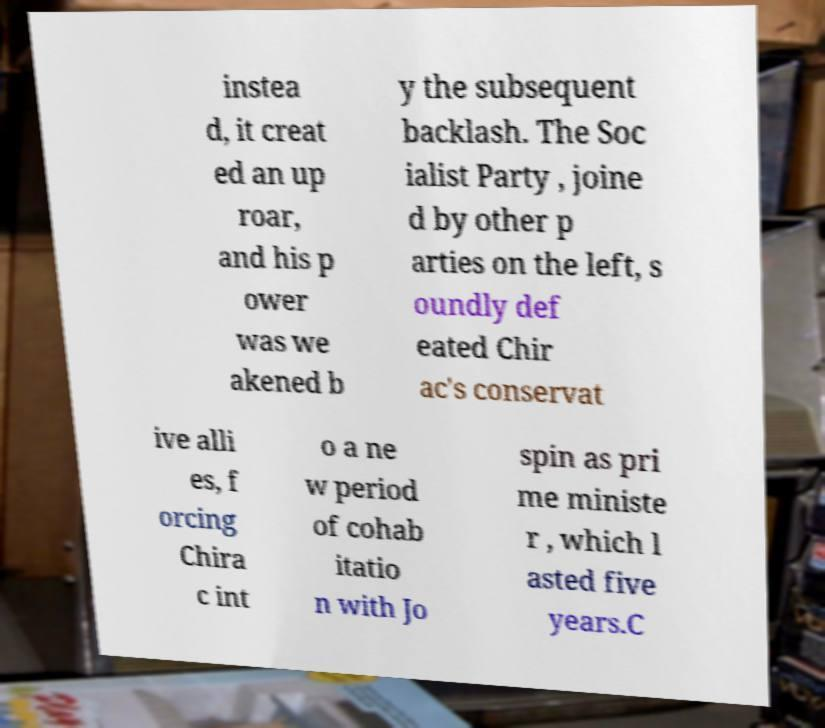Can you accurately transcribe the text from the provided image for me? instea d, it creat ed an up roar, and his p ower was we akened b y the subsequent backlash. The Soc ialist Party , joine d by other p arties on the left, s oundly def eated Chir ac's conservat ive alli es, f orcing Chira c int o a ne w period of cohab itatio n with Jo spin as pri me ministe r , which l asted five years.C 